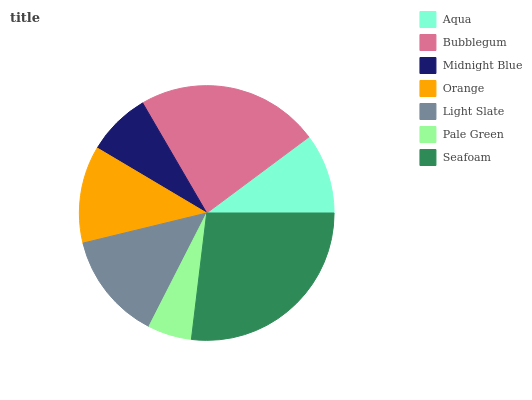Is Pale Green the minimum?
Answer yes or no. Yes. Is Seafoam the maximum?
Answer yes or no. Yes. Is Bubblegum the minimum?
Answer yes or no. No. Is Bubblegum the maximum?
Answer yes or no. No. Is Bubblegum greater than Aqua?
Answer yes or no. Yes. Is Aqua less than Bubblegum?
Answer yes or no. Yes. Is Aqua greater than Bubblegum?
Answer yes or no. No. Is Bubblegum less than Aqua?
Answer yes or no. No. Is Orange the high median?
Answer yes or no. Yes. Is Orange the low median?
Answer yes or no. Yes. Is Midnight Blue the high median?
Answer yes or no. No. Is Aqua the low median?
Answer yes or no. No. 